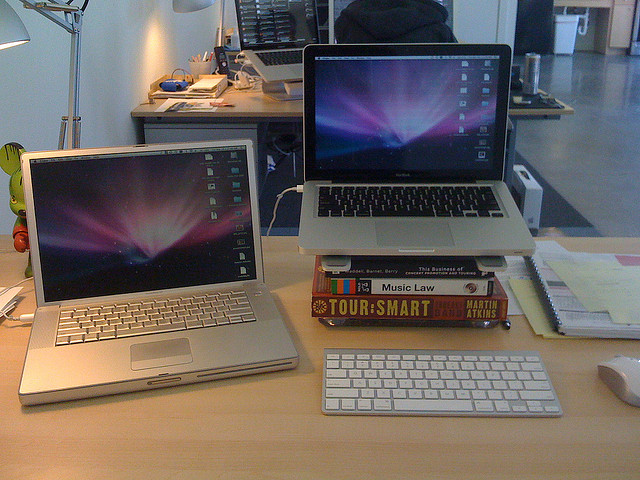Identify the text contained in this image. Music Law TOUR SMART MARTIR ATKINS 